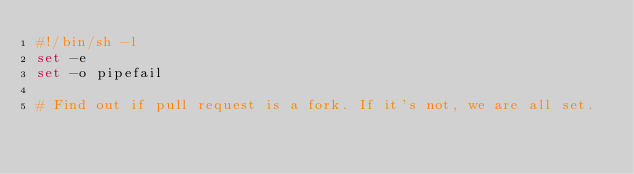Convert code to text. <code><loc_0><loc_0><loc_500><loc_500><_Bash_>#!/bin/sh -l
set -e
set -o pipefail

# Find out if pull request is a fork. If it's not, we are all set.</code> 